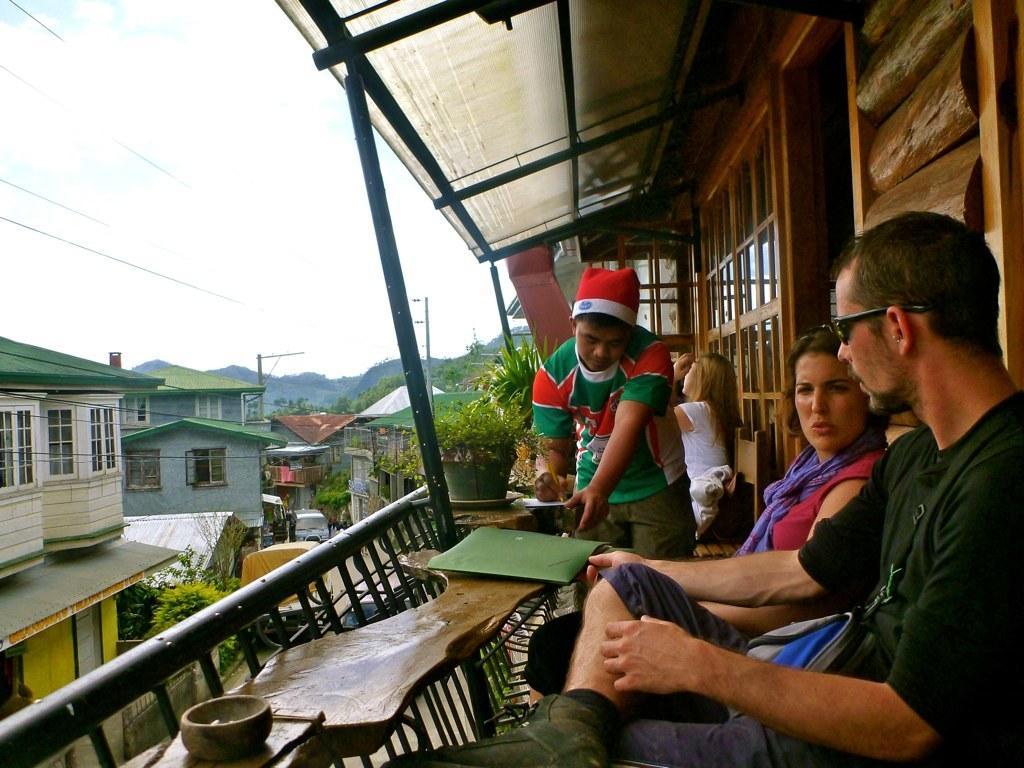Describe this image in one or two sentences. On the right side we can see some persons were sitting on chair. And in center we can see one man standing and writing something on the paper. And on the left side we can see the building and sky with clouds,mountains ,trees and plants. 